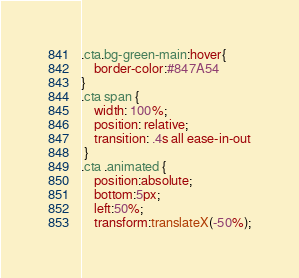<code> <loc_0><loc_0><loc_500><loc_500><_CSS_>.cta.bg-green-main:hover{
    border-color:#847A54
}
.cta span {
    width: 100%;
    position: relative;
    transition: .4s all ease-in-out
 }
.cta .animated {
    position:absolute;
    bottom:5px;
    left:50%;
    transform:translateX(-50%);</code> 